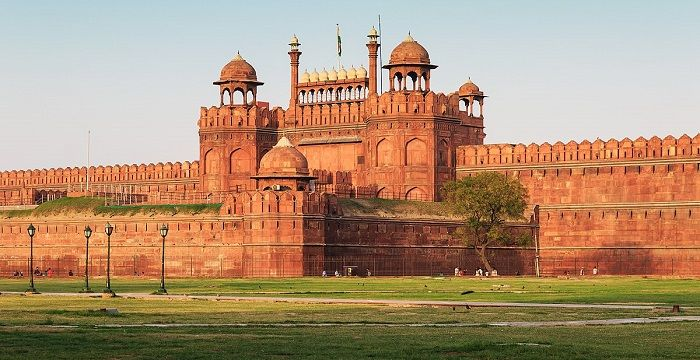Can you tell me more about the architectural styles reflected in the fort? Certainly! The Red Fort is a quintessential example of Mughal architecture, which blends Persian, Timurid, and Hindu styles. Highlighted in the fort's design are high arches and domes, intricate carvings, and the extensive use of red sandstone. Notably, the fort's walls are adorned with floral decorations and calligraphic inscriptions, showcasing superb craftsmanship. The use of marble in key areas such as the Diwan-i-Aam (Hall of Public Audience) adds to the aesthetic allure and grandeur of the structure. 